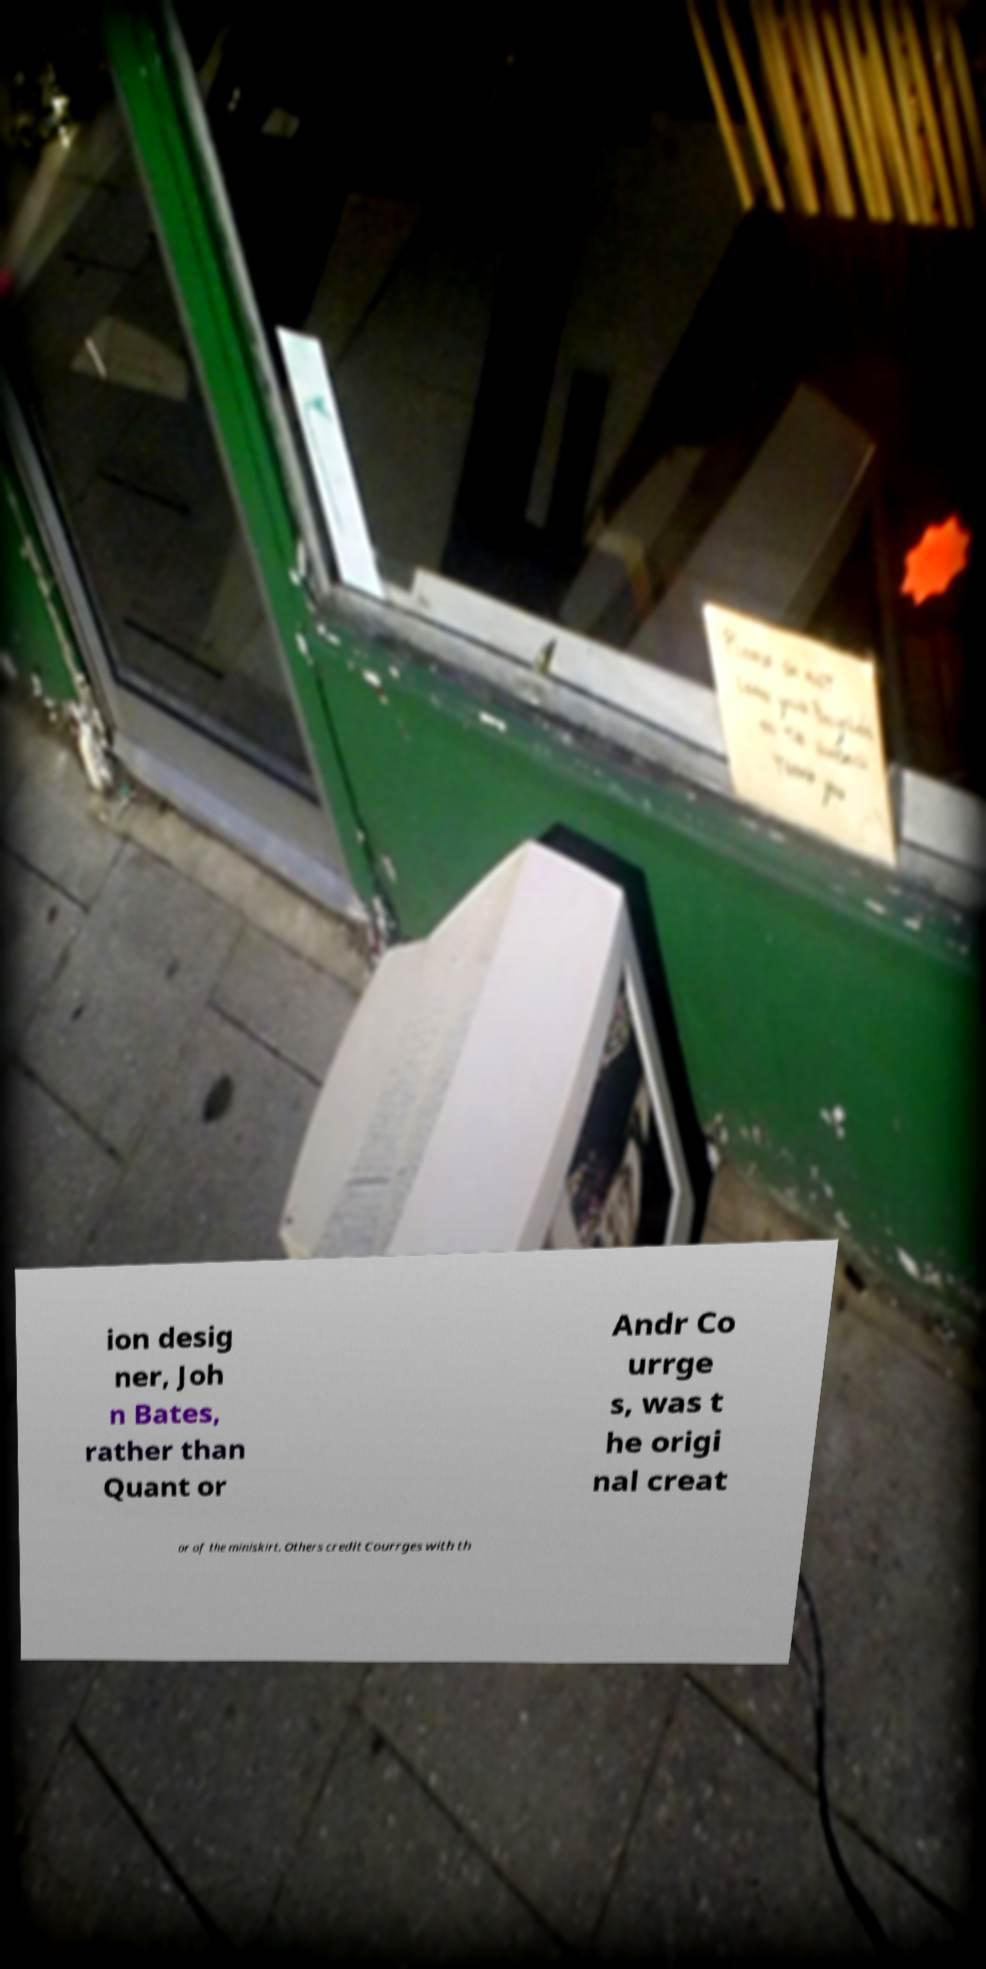Can you read and provide the text displayed in the image?This photo seems to have some interesting text. Can you extract and type it out for me? ion desig ner, Joh n Bates, rather than Quant or Andr Co urrge s, was t he origi nal creat or of the miniskirt. Others credit Courrges with th 